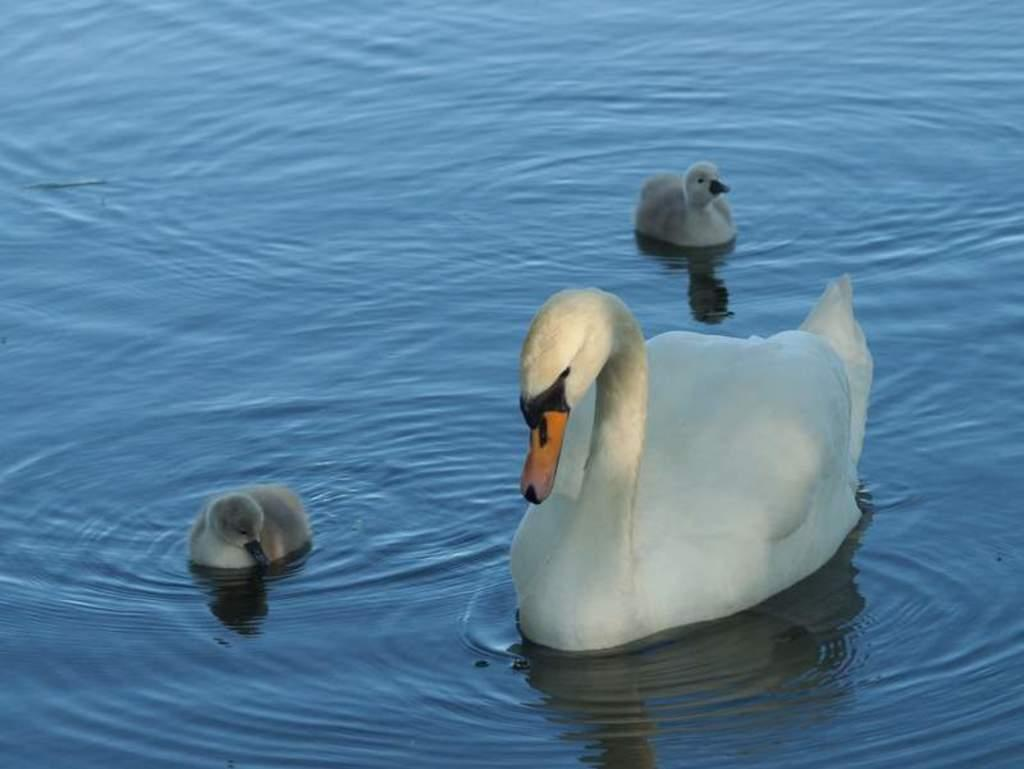What type of bird is present in the image? There is a swan in the image. Are there any baby swans in the image? Yes, there are cygnets in the image. Where are the swan and cygnets located in relation to the water? The swan and cygnets are above the water. Can you tell me how many strangers are present in the image? There is no stranger present in the image; it features a swan and cygnets. What type of cushion can be seen supporting the swan in the image? There is no cushion present in the image; the swan and cygnets are above the water. 